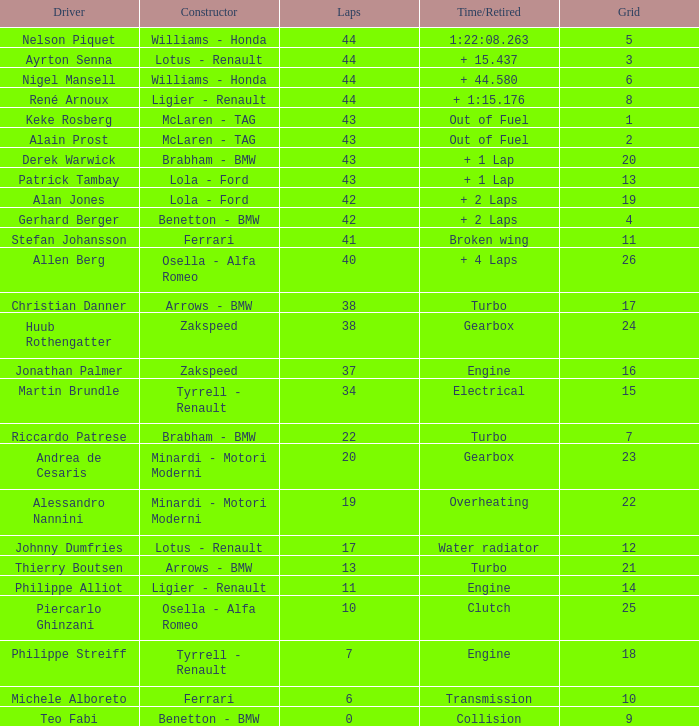Tell me the time/retired for Laps of 42 and Grids of 4 + 2 Laps. Help me parse the entirety of this table. {'header': ['Driver', 'Constructor', 'Laps', 'Time/Retired', 'Grid'], 'rows': [['Nelson Piquet', 'Williams - Honda', '44', '1:22:08.263', '5'], ['Ayrton Senna', 'Lotus - Renault', '44', '+ 15.437', '3'], ['Nigel Mansell', 'Williams - Honda', '44', '+ 44.580', '6'], ['René Arnoux', 'Ligier - Renault', '44', '+ 1:15.176', '8'], ['Keke Rosberg', 'McLaren - TAG', '43', 'Out of Fuel', '1'], ['Alain Prost', 'McLaren - TAG', '43', 'Out of Fuel', '2'], ['Derek Warwick', 'Brabham - BMW', '43', '+ 1 Lap', '20'], ['Patrick Tambay', 'Lola - Ford', '43', '+ 1 Lap', '13'], ['Alan Jones', 'Lola - Ford', '42', '+ 2 Laps', '19'], ['Gerhard Berger', 'Benetton - BMW', '42', '+ 2 Laps', '4'], ['Stefan Johansson', 'Ferrari', '41', 'Broken wing', '11'], ['Allen Berg', 'Osella - Alfa Romeo', '40', '+ 4 Laps', '26'], ['Christian Danner', 'Arrows - BMW', '38', 'Turbo', '17'], ['Huub Rothengatter', 'Zakspeed', '38', 'Gearbox', '24'], ['Jonathan Palmer', 'Zakspeed', '37', 'Engine', '16'], ['Martin Brundle', 'Tyrrell - Renault', '34', 'Electrical', '15'], ['Riccardo Patrese', 'Brabham - BMW', '22', 'Turbo', '7'], ['Andrea de Cesaris', 'Minardi - Motori Moderni', '20', 'Gearbox', '23'], ['Alessandro Nannini', 'Minardi - Motori Moderni', '19', 'Overheating', '22'], ['Johnny Dumfries', 'Lotus - Renault', '17', 'Water radiator', '12'], ['Thierry Boutsen', 'Arrows - BMW', '13', 'Turbo', '21'], ['Philippe Alliot', 'Ligier - Renault', '11', 'Engine', '14'], ['Piercarlo Ghinzani', 'Osella - Alfa Romeo', '10', 'Clutch', '25'], ['Philippe Streiff', 'Tyrrell - Renault', '7', 'Engine', '18'], ['Michele Alboreto', 'Ferrari', '6', 'Transmission', '10'], ['Teo Fabi', 'Benetton - BMW', '0', 'Collision', '9']]} 